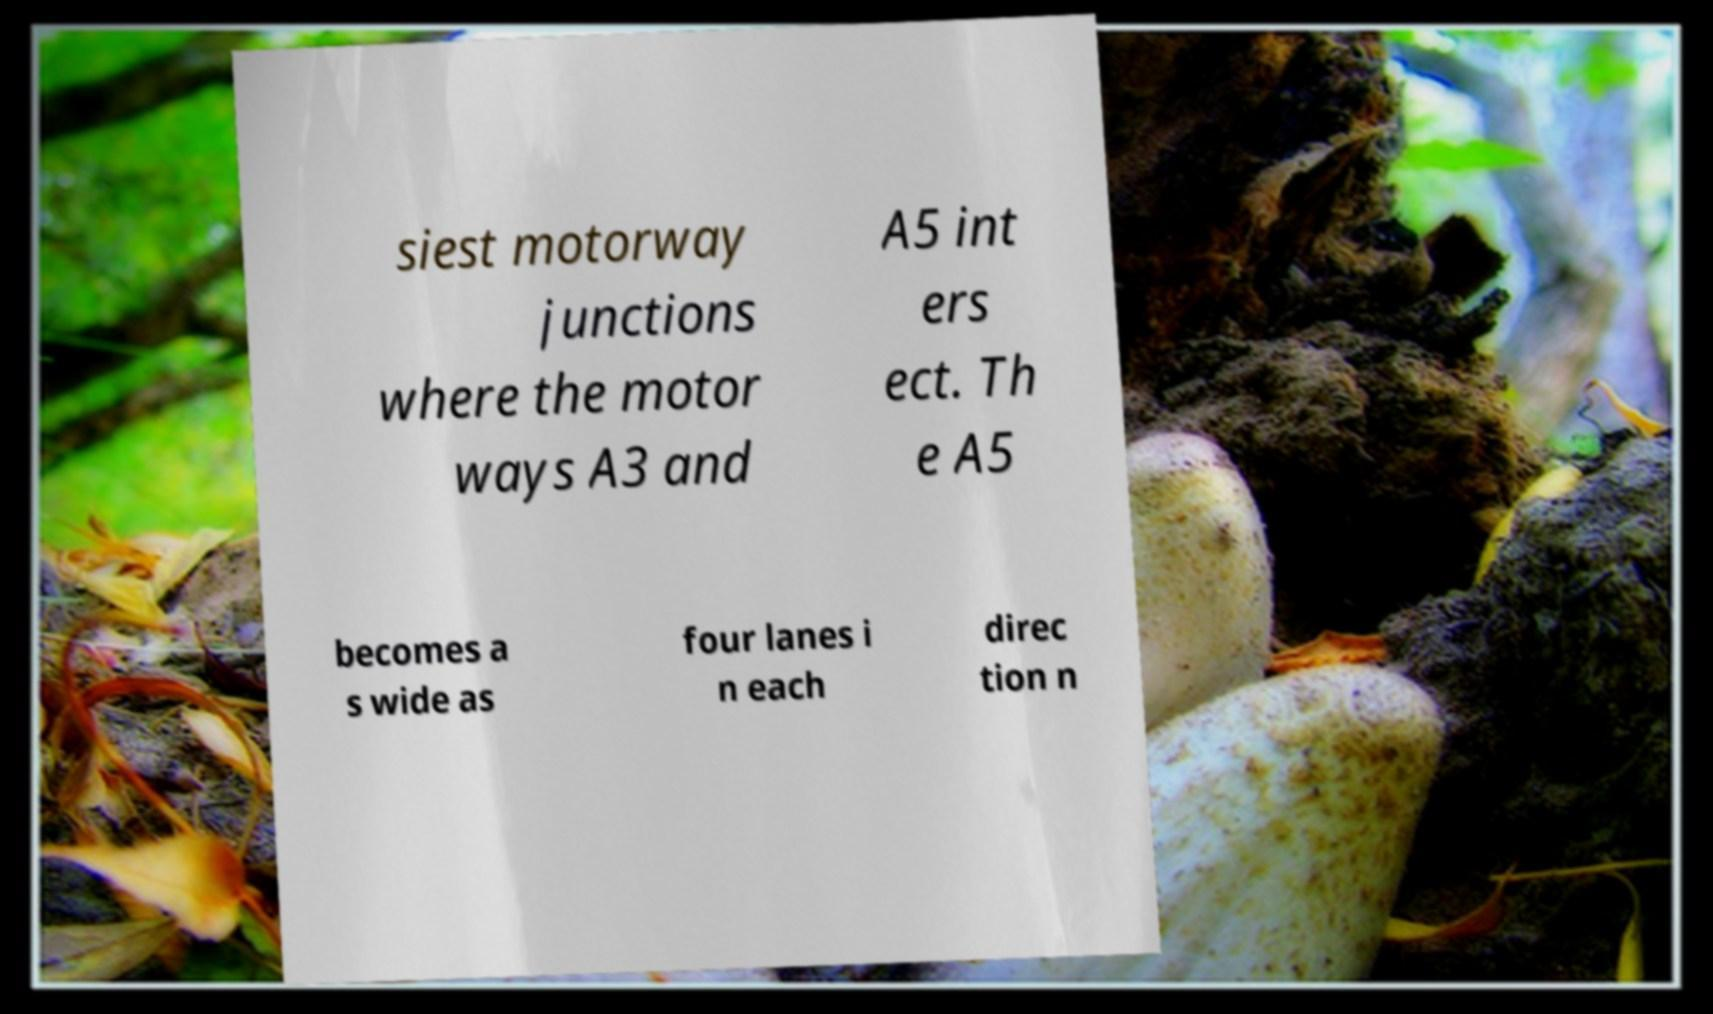Can you read and provide the text displayed in the image?This photo seems to have some interesting text. Can you extract and type it out for me? siest motorway junctions where the motor ways A3 and A5 int ers ect. Th e A5 becomes a s wide as four lanes i n each direc tion n 